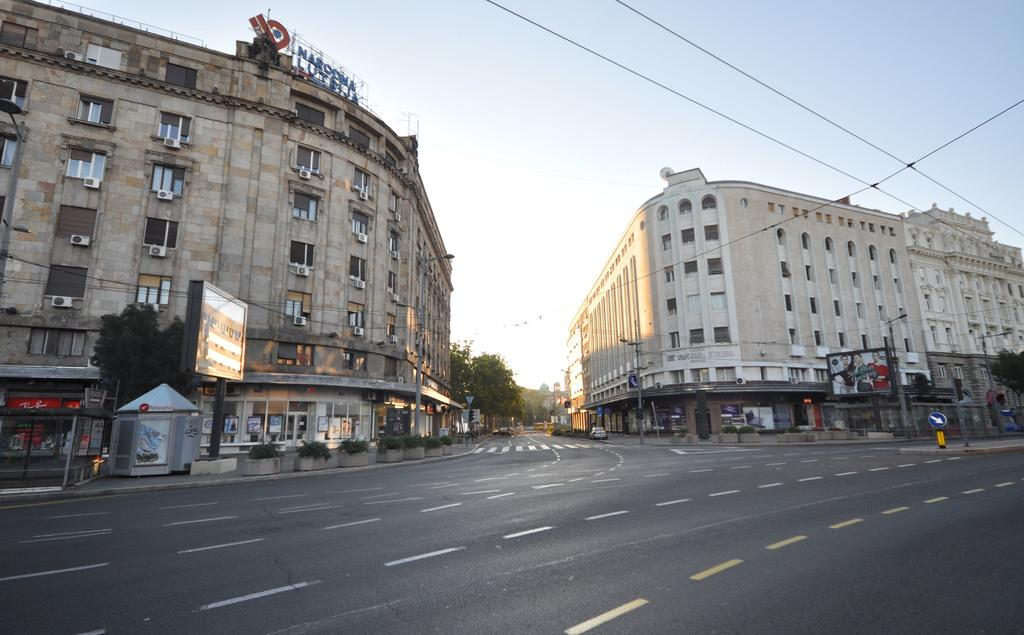What type of structures are visible in the image? There are buildings with windows in the image. What is placed in front of the buildings? There are hoardings and trees in front of the buildings. Are there any plants visible in the image? Yes, there are plants in front of the buildings. What can be seen on the buildings or nearby structures? There is a signboard in the image. What else is present in the image? There is a vehicle in the image. What time does the watch on the building show in the image? There is no watch present on the building in the image. 